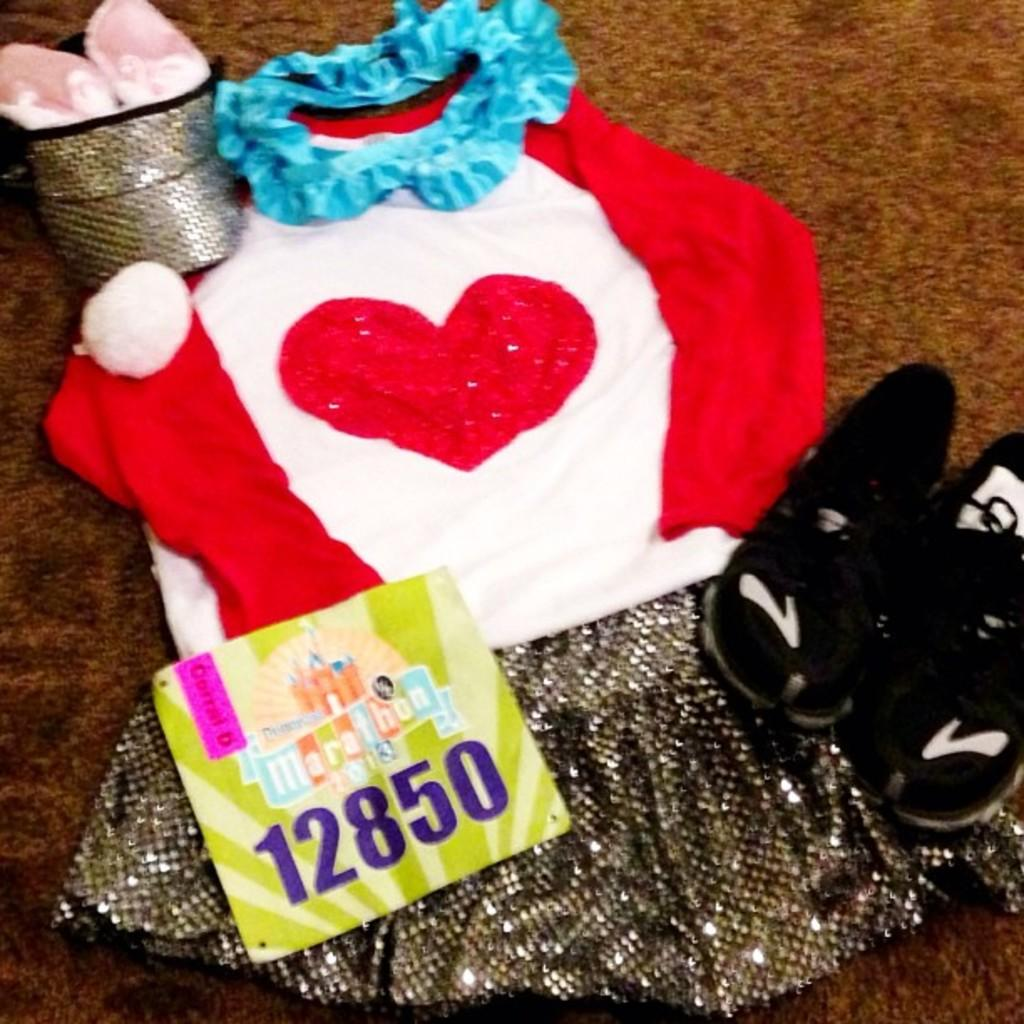What type of clothing item is in the image? There is a dress in the image. What footwear is also visible in the image? There are shoes in the image. Where are the dress and shoes placed? The dress and shoes are placed on a carpet. What other item can be seen in the image? There is a card in the image. How is the card positioned in relation to the dress? The card is placed above the dress. What type of wool is used to make the pear visible in the image? There is no pear present in the image, and therefore no wool can be associated with it. 